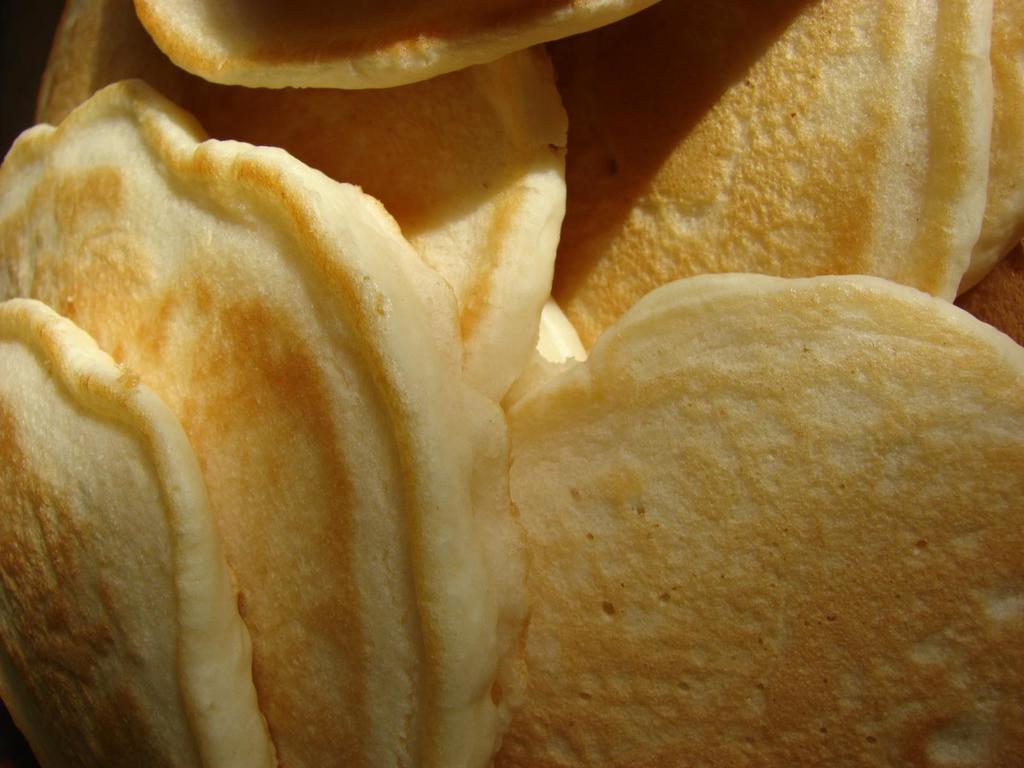Describe this image in one or two sentences. In this image, we can see some food. 